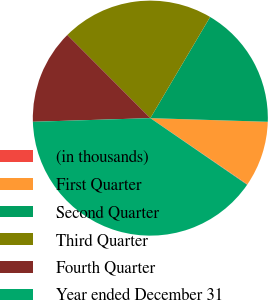Convert chart. <chart><loc_0><loc_0><loc_500><loc_500><pie_chart><fcel>(in thousands)<fcel>First Quarter<fcel>Second Quarter<fcel>Third Quarter<fcel>Fourth Quarter<fcel>Year ended December 31<nl><fcel>0.07%<fcel>9.03%<fcel>17.0%<fcel>20.98%<fcel>13.01%<fcel>39.91%<nl></chart> 